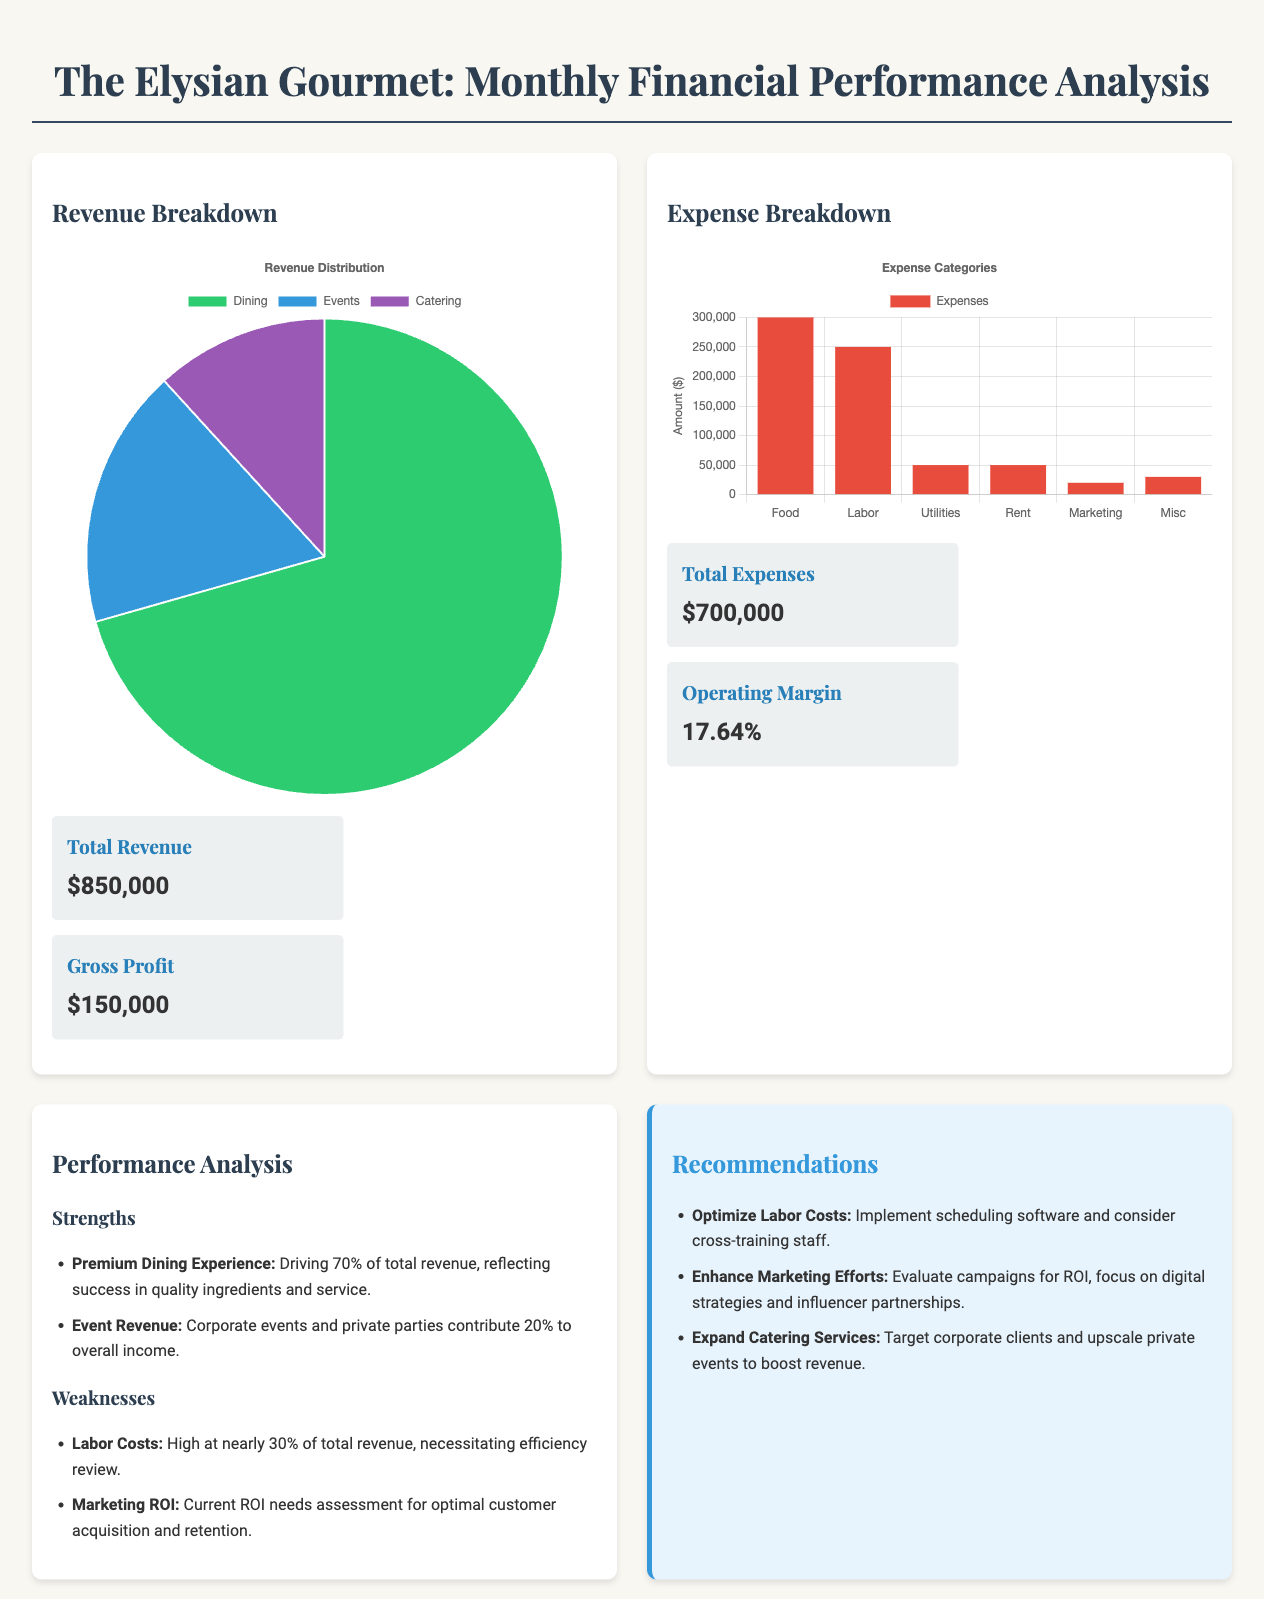what is the total revenue? The total revenue is listed in the revenue section of the document, which states it is $850,000.
Answer: $850,000 what is the operating margin? The operating margin is provided in the expense section of the document, listed as 17.64%.
Answer: 17.64% which category drives 70% of the total revenue? The document states that the premium dining experience contributes 70% to total revenue.
Answer: Premium Dining Experience how much do labor costs account for of total revenue? The document mentions that labor costs are high at nearly 30% of total revenue.
Answer: Nearly 30% what percentage of total revenue is contributed by event revenue? The document specifies that event revenue contributes 20% to overall income.
Answer: 20% what recommendation is made regarding labor costs? The document recommends implementing scheduling software and considering cross-training staff to optimize labor costs.
Answer: Optimize Labor Costs how much are total expenses? The total expenses are specified in the expense section, which states they amount to $700,000.
Answer: $700,000 what is the amount allocated for food expenses? The document indicates that food expenses total $300,000.
Answer: $300,000 what is the product of the recommendations? Recommendations section highlights focusing on digital strategies and influencer partnerships for better marketing effectiveness.
Answer: Enhance Marketing Efforts 